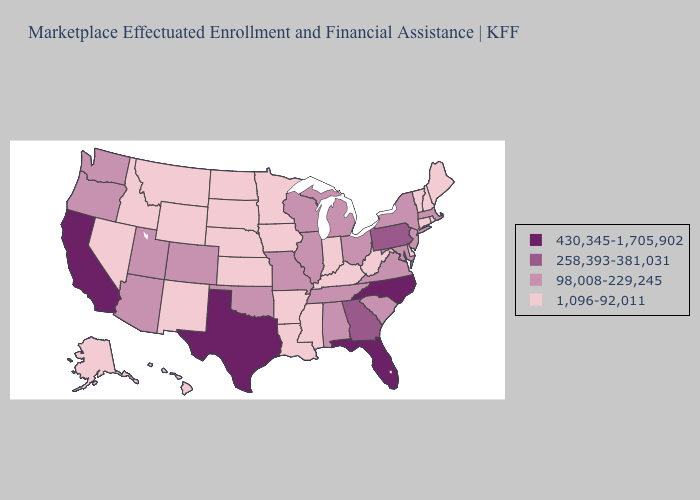Does Wyoming have a lower value than South Carolina?
Write a very short answer. Yes. Does Minnesota have the lowest value in the MidWest?
Give a very brief answer. Yes. Does Arkansas have the same value as New York?
Answer briefly. No. Does New Mexico have a lower value than Connecticut?
Quick response, please. No. Name the states that have a value in the range 430,345-1,705,902?
Give a very brief answer. California, Florida, North Carolina, Texas. Does the map have missing data?
Give a very brief answer. No. Name the states that have a value in the range 430,345-1,705,902?
Write a very short answer. California, Florida, North Carolina, Texas. Among the states that border Colorado , does Oklahoma have the lowest value?
Concise answer only. No. Name the states that have a value in the range 1,096-92,011?
Be succinct. Alaska, Arkansas, Connecticut, Delaware, Hawaii, Idaho, Indiana, Iowa, Kansas, Kentucky, Louisiana, Maine, Minnesota, Mississippi, Montana, Nebraska, Nevada, New Hampshire, New Mexico, North Dakota, Rhode Island, South Dakota, Vermont, West Virginia, Wyoming. What is the value of Indiana?
Answer briefly. 1,096-92,011. What is the value of Missouri?
Quick response, please. 98,008-229,245. Name the states that have a value in the range 1,096-92,011?
Quick response, please. Alaska, Arkansas, Connecticut, Delaware, Hawaii, Idaho, Indiana, Iowa, Kansas, Kentucky, Louisiana, Maine, Minnesota, Mississippi, Montana, Nebraska, Nevada, New Hampshire, New Mexico, North Dakota, Rhode Island, South Dakota, Vermont, West Virginia, Wyoming. Does Virginia have a higher value than West Virginia?
Quick response, please. Yes. What is the value of Massachusetts?
Answer briefly. 98,008-229,245. What is the value of Florida?
Quick response, please. 430,345-1,705,902. 